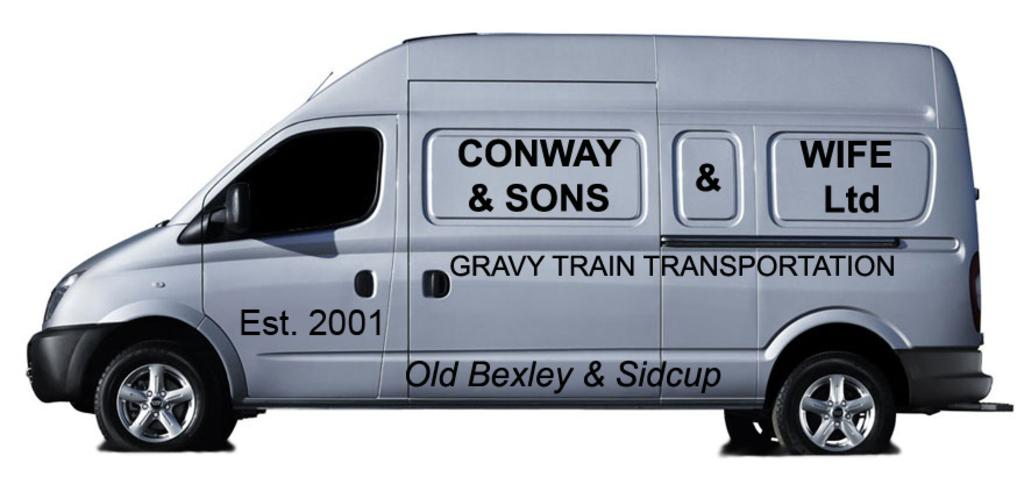What is the main subject of the image? There is a vehicle in the image. What can be seen on the vehicle? There is text on the vehicle. What color is the background of the image? The background of the image is white. How many icicles are hanging from the vehicle in the image? There are no icicles present in the image. What type of chairs can be seen inside the vehicle? There are no chairs visible in the image, as it only features a vehicle with text on it against a white background. 